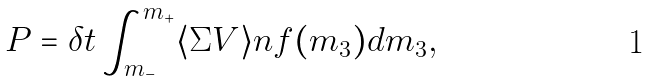Convert formula to latex. <formula><loc_0><loc_0><loc_500><loc_500>P = \delta t \int _ { m _ { - } } ^ { m _ { + } } \langle \Sigma V \rangle n f ( m _ { 3 } ) d m _ { 3 } ,</formula> 